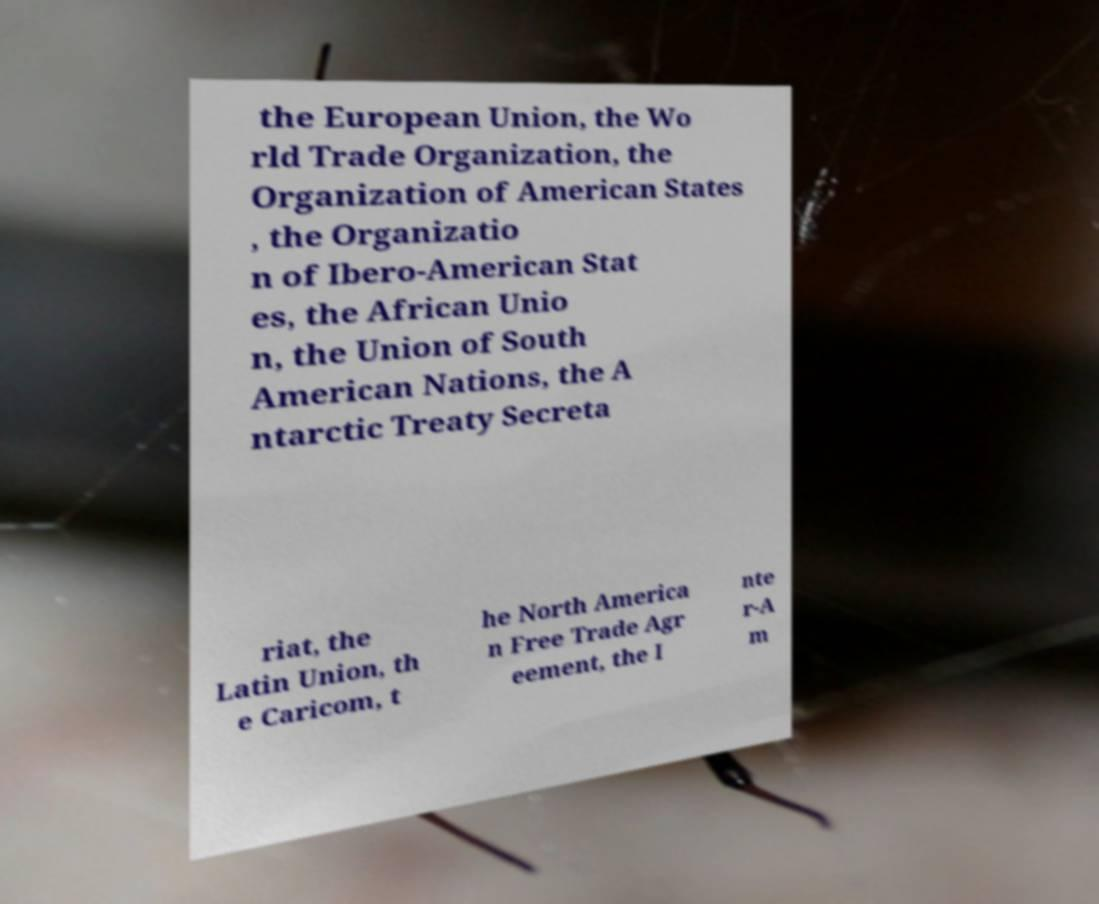What messages or text are displayed in this image? I need them in a readable, typed format. the European Union, the Wo rld Trade Organization, the Organization of American States , the Organizatio n of Ibero-American Stat es, the African Unio n, the Union of South American Nations, the A ntarctic Treaty Secreta riat, the Latin Union, th e Caricom, t he North America n Free Trade Agr eement, the I nte r-A m 